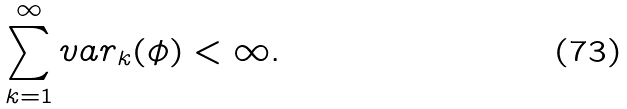Convert formula to latex. <formula><loc_0><loc_0><loc_500><loc_500>\sum _ { k = 1 } ^ { \infty } v a r _ { k } ( \phi ) < \infty .</formula> 